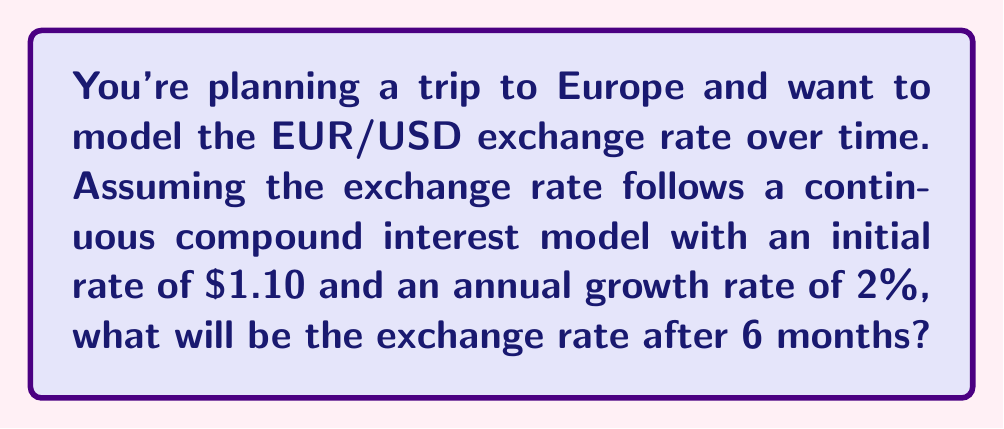Show me your answer to this math problem. Let's approach this step-by-step using the continuous compound interest formula:

1) The formula for continuous compound interest is:
   $$A = P e^{rt}$$
   where:
   $A$ = final amount
   $P$ = initial amount
   $e$ = Euler's number (approximately 2.71828)
   $r$ = growth rate (as a decimal)
   $t$ = time in years

2) We know:
   $P = 1.10$ (initial exchange rate)
   $r = 0.02$ (2% annual growth rate)
   $t = 0.5$ (6 months = 0.5 years)

3) Plugging these values into the formula:
   $$A = 1.10 \cdot e^{0.02 \cdot 0.5}$$

4) Simplify the exponent:
   $$A = 1.10 \cdot e^{0.01}$$

5) Calculate $e^{0.01}$ (you can use a calculator for this):
   $$e^{0.01} \approx 1.01005$$

6) Multiply:
   $$A = 1.10 \cdot 1.01005 \approx 1.11106$$

Therefore, after 6 months, the exchange rate will be approximately 1.11106 EUR/USD.
Answer: $1.11106$ EUR/USD 